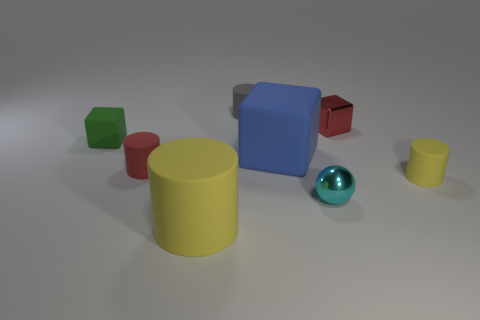How big is the matte block on the right side of the tiny green thing on the left side of the large yellow thing that is left of the tiny gray cylinder?
Your response must be concise. Large. There is a tiny red object that is to the left of the tiny matte object that is behind the tiny object to the left of the red matte thing; what is its shape?
Ensure brevity in your answer.  Cylinder. There is a small red thing behind the green thing; what is its shape?
Offer a terse response. Cube. Does the large cylinder have the same material as the cube in front of the green object?
Provide a short and direct response. Yes. What number of other things are the same shape as the large blue matte object?
Make the answer very short. 2. Does the ball have the same color as the large object that is in front of the red cylinder?
Your answer should be very brief. No. Are there any other things that have the same material as the sphere?
Provide a short and direct response. Yes. What shape is the small red object left of the yellow matte cylinder that is in front of the cyan metallic thing?
Your response must be concise. Cylinder. There is a small metallic thing that is behind the small green rubber thing; is it the same shape as the small red matte object?
Give a very brief answer. No. Are there more tiny things on the right side of the green matte object than red rubber objects that are right of the red cylinder?
Your response must be concise. Yes. 